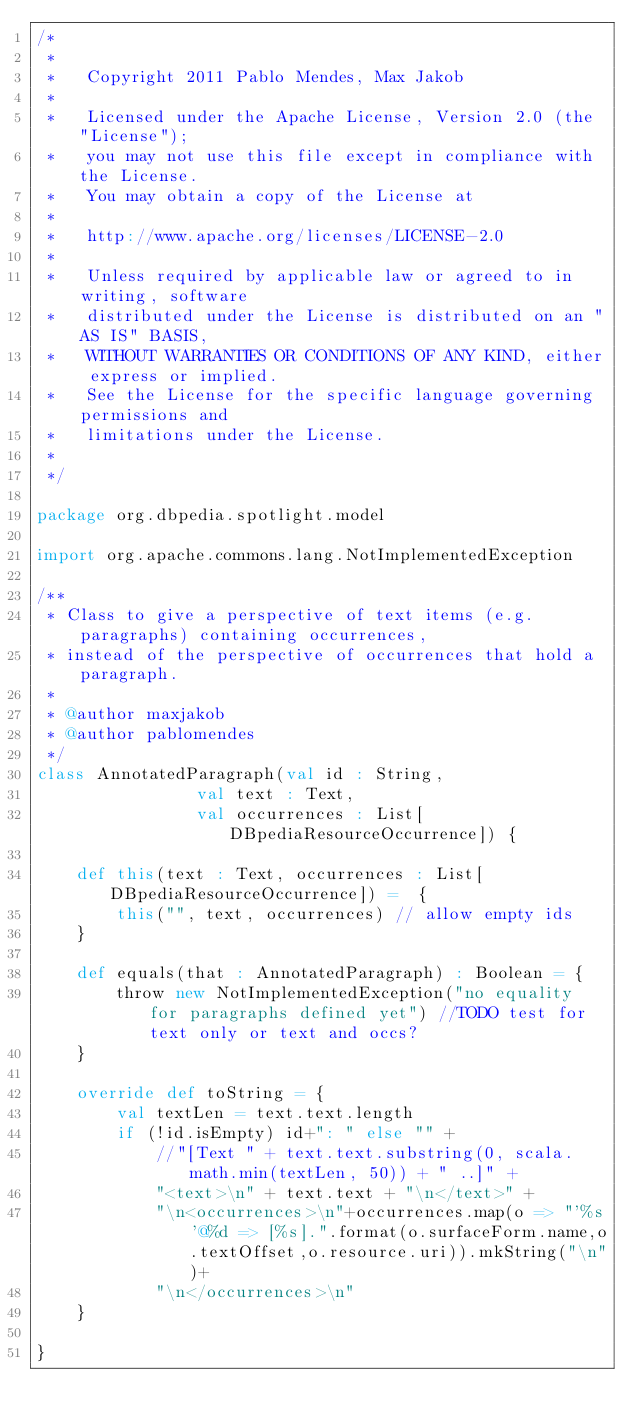Convert code to text. <code><loc_0><loc_0><loc_500><loc_500><_Scala_>/*
 *
 *   Copyright 2011 Pablo Mendes, Max Jakob
 *
 *   Licensed under the Apache License, Version 2.0 (the "License");
 *   you may not use this file except in compliance with the License.
 *   You may obtain a copy of the License at
 *
 *   http://www.apache.org/licenses/LICENSE-2.0
 *
 *   Unless required by applicable law or agreed to in writing, software
 *   distributed under the License is distributed on an "AS IS" BASIS,
 *   WITHOUT WARRANTIES OR CONDITIONS OF ANY KIND, either express or implied.
 *   See the License for the specific language governing permissions and
 *   limitations under the License.
 *
 */

package org.dbpedia.spotlight.model

import org.apache.commons.lang.NotImplementedException

/**
 * Class to give a perspective of text items (e.g. paragraphs) containing occurrences,
 * instead of the perspective of occurrences that hold a paragraph.
 *
 * @author maxjakob
 * @author pablomendes
 */
class AnnotatedParagraph(val id : String,
                val text : Text,
                val occurrences : List[DBpediaResourceOccurrence]) {

    def this(text : Text, occurrences : List[DBpediaResourceOccurrence]) =  {
        this("", text, occurrences) // allow empty ids
    }

    def equals(that : AnnotatedParagraph) : Boolean = {
        throw new NotImplementedException("no equality for paragraphs defined yet") //TODO test for text only or text and occs?
    }

    override def toString = {
        val textLen = text.text.length
        if (!id.isEmpty) id+": " else "" +
            //"[Text " + text.text.substring(0, scala.math.min(textLen, 50)) + " ..]" +
            "<text>\n" + text.text + "\n</text>" +
            "\n<occurrences>\n"+occurrences.map(o => "'%s'@%d => [%s].".format(o.surfaceForm.name,o.textOffset,o.resource.uri)).mkString("\n")+
            "\n</occurrences>\n"
    }

}</code> 